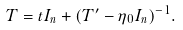Convert formula to latex. <formula><loc_0><loc_0><loc_500><loc_500>T = t I _ { n } + ( T ^ { \prime } - \eta _ { 0 } I _ { n } ) ^ { - 1 } .</formula> 